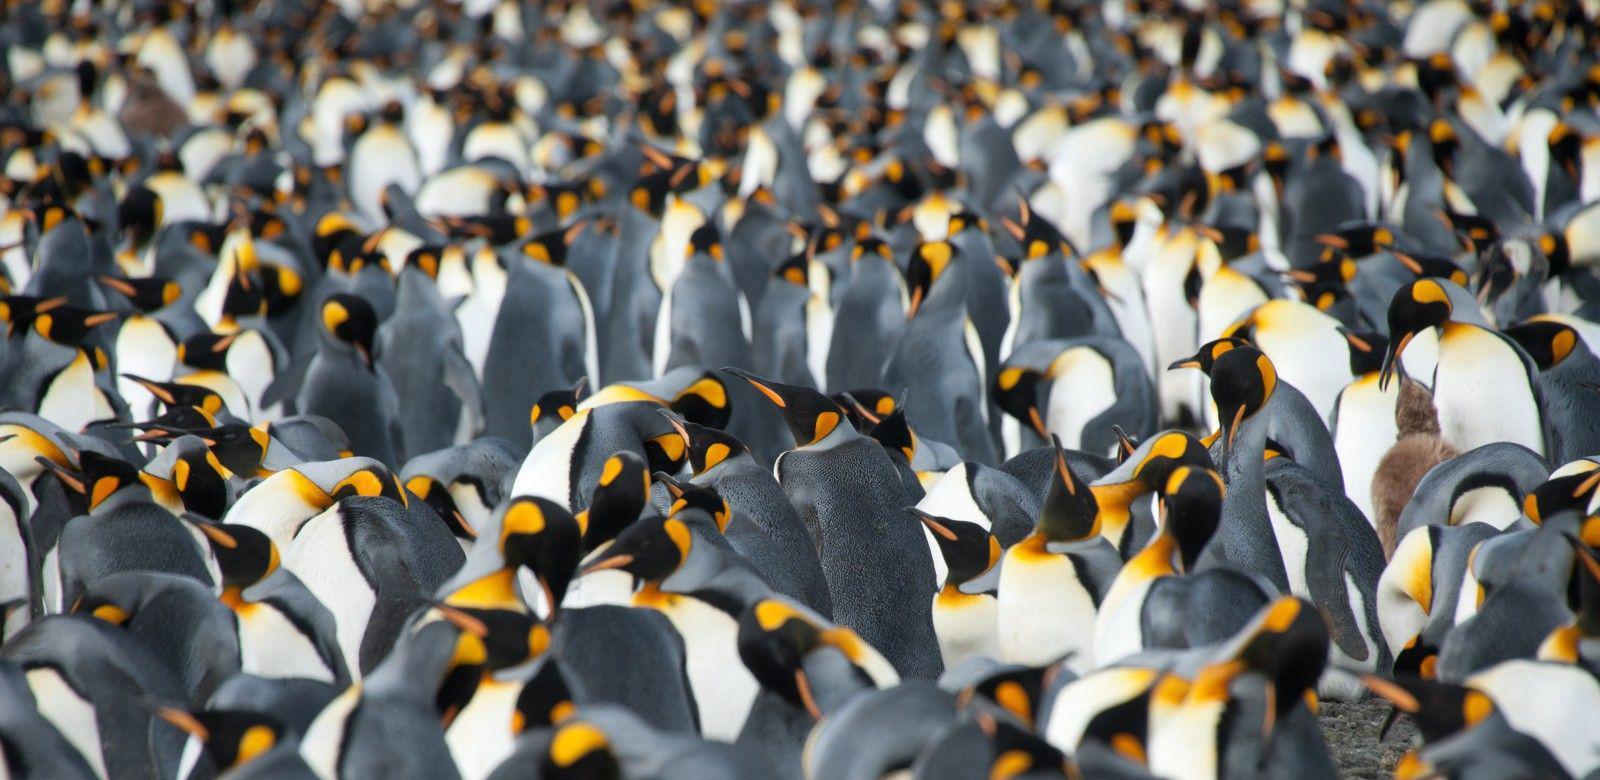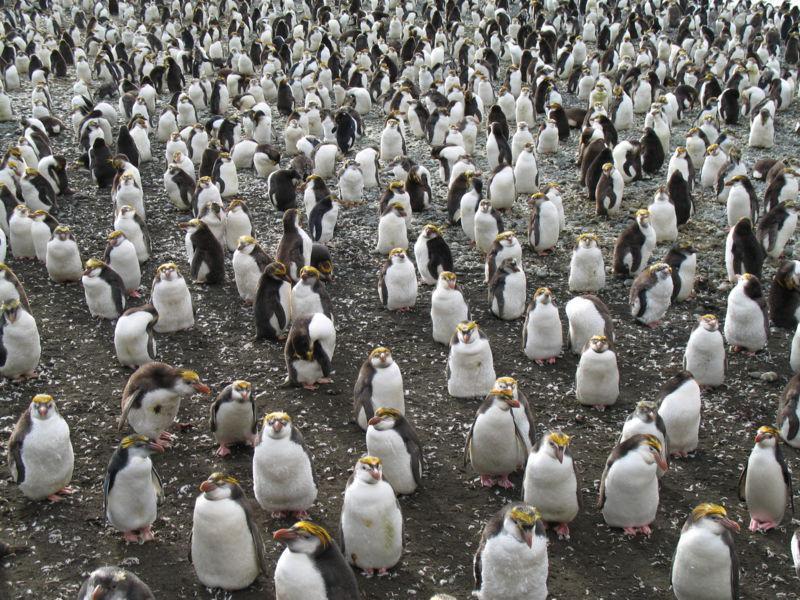The first image is the image on the left, the second image is the image on the right. Examine the images to the left and right. Is the description "One image shows just two penguins side-by-side, with faces turned inward." accurate? Answer yes or no. No. The first image is the image on the left, the second image is the image on the right. For the images displayed, is the sentence "There are two penguins in the left image" factually correct? Answer yes or no. No. 